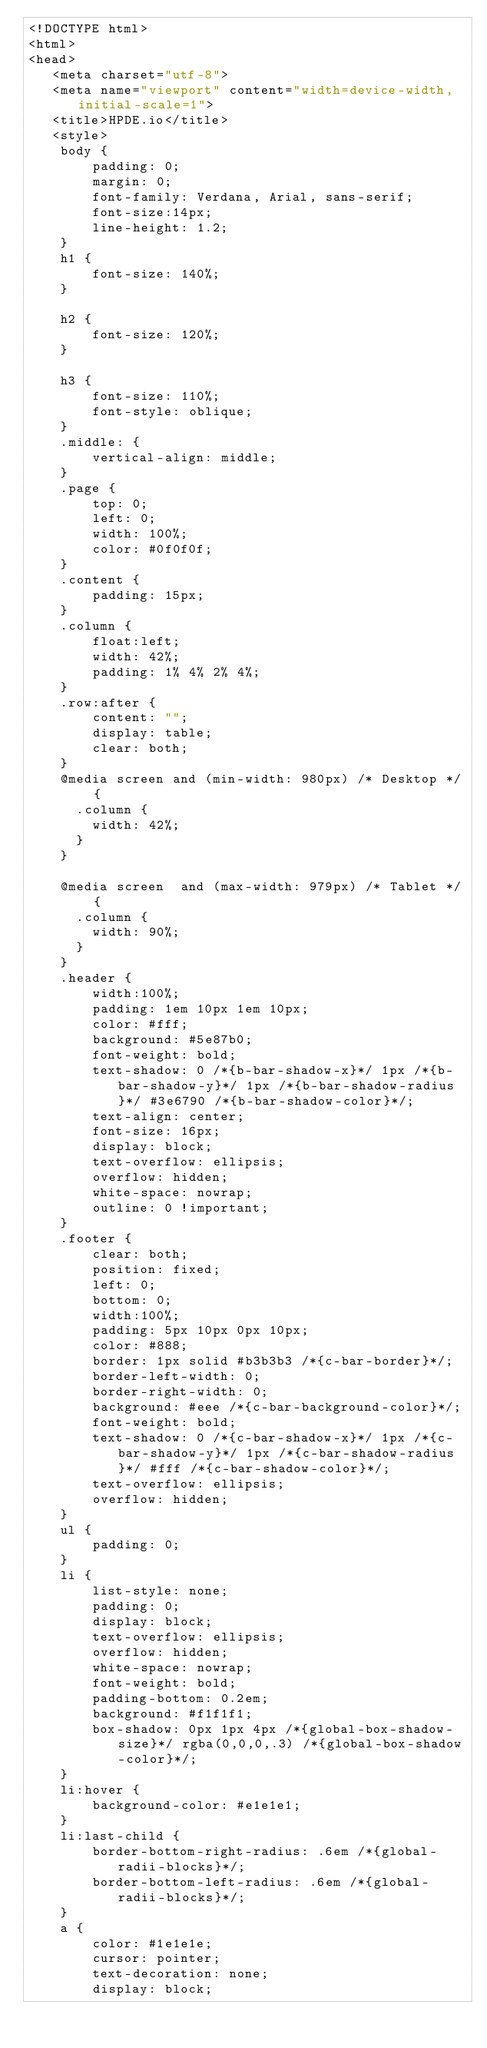<code> <loc_0><loc_0><loc_500><loc_500><_HTML_><!DOCTYPE html>
<html>
<head>
   <meta charset="utf-8">
   <meta name="viewport" content="width=device-width, initial-scale=1">
   <title>HPDE.io</title>
   <style>
	body {
		padding: 0;
		margin: 0;
		font-family: Verdana, Arial, sans-serif; 
		font-size:14px; 
		line-height: 1.2;
	}
	h1 {
		font-size: 140%;
	}

	h2 {
		font-size: 120%;
	}

	h3 {
		font-size: 110%;
		font-style: oblique;
	}
	.middle: {
		vertical-align: middle;
	}
	.page {
		top: 0;
		left: 0;
		width: 100%;
		color: #0f0f0f;
	}
	.content {
		padding: 15px;
	}
	.column {
		float:left;
		width: 42%;
		padding: 1% 4% 2% 4%;
	}
	.row:after {
		content: "";
		display: table;
		clear: both;
	}	
	@media screen and (min-width: 980px) /* Desktop */ {
	  .column {
		width: 42%;
	  }
	}

	@media screen  and (max-width: 979px) /* Tablet */ {
	  .column {
		width: 90%;
	  }
	}
	.header {
		width:100%;
		padding: 1em 10px 1em 10px;
		color: #fff;
		background: #5e87b0;
		font-weight: bold;
		text-shadow: 0 /*{b-bar-shadow-x}*/ 1px /*{b-bar-shadow-y}*/ 1px /*{b-bar-shadow-radius}*/ #3e6790 /*{b-bar-shadow-color}*/;
		text-align: center;
		font-size: 16px;
		display: block;
		text-overflow: ellipsis;
		overflow: hidden;
		white-space: nowrap;
		outline: 0 !important;
	}
	.footer {
		clear: both;
		position: fixed;
		left: 0;
		bottom: 0;
		width:100%;
		padding: 5px 10px 0px 10px;
		color: #888;
		border: 1px solid #b3b3b3 /*{c-bar-border}*/;
		border-left-width: 0;
		border-right-width: 0;
		background: #eee /*{c-bar-background-color}*/;
		font-weight: bold;
		text-shadow: 0 /*{c-bar-shadow-x}*/ 1px /*{c-bar-shadow-y}*/ 1px /*{c-bar-shadow-radius}*/ #fff /*{c-bar-shadow-color}*/;
		text-overflow: ellipsis;
		overflow: hidden;
	}
	ul {
		padding: 0;
	}
	li {
		list-style: none;
		padding: 0;
		display: block;
	    text-overflow: ellipsis;
		overflow: hidden;
		white-space: nowrap;
		font-weight: bold;
		padding-bottom: 0.2em;
		background: #f1f1f1;
		box-shadow: 0px 1px 4px /*{global-box-shadow-size}*/ rgba(0,0,0,.3) /*{global-box-shadow-color}*/;
	}
	li:hover {
		background-color: #e1e1e1;
	}
	li:last-child {
		border-bottom-right-radius: .6em /*{global-radii-blocks}*/;
		border-bottom-left-radius: .6em /*{global-radii-blocks}*/;
	}
	a {
		color: #1e1e1e;
		cursor: pointer;
		text-decoration: none;
		display: block;</code> 